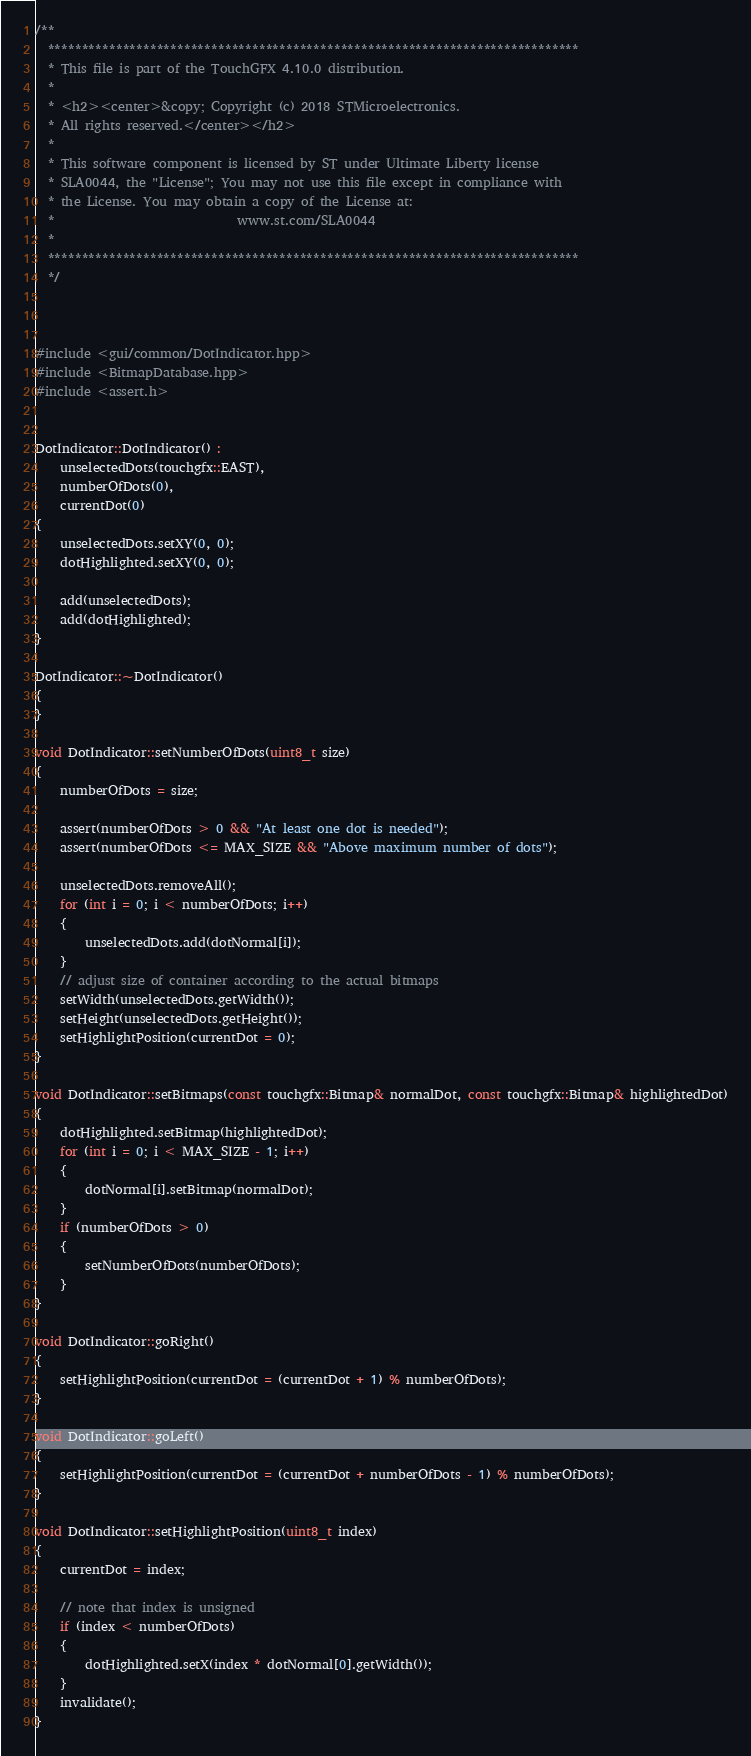Convert code to text. <code><loc_0><loc_0><loc_500><loc_500><_C++_>/**
  ******************************************************************************
  * This file is part of the TouchGFX 4.10.0 distribution.
  *
  * <h2><center>&copy; Copyright (c) 2018 STMicroelectronics.
  * All rights reserved.</center></h2>
  *
  * This software component is licensed by ST under Ultimate Liberty license
  * SLA0044, the "License"; You may not use this file except in compliance with
  * the License. You may obtain a copy of the License at:
  *                             www.st.com/SLA0044
  *
  ******************************************************************************
  */
  


#include <gui/common/DotIndicator.hpp>
#include <BitmapDatabase.hpp>
#include <assert.h>


DotIndicator::DotIndicator() :
    unselectedDots(touchgfx::EAST),
    numberOfDots(0),
    currentDot(0)
{
    unselectedDots.setXY(0, 0);
    dotHighlighted.setXY(0, 0);

    add(unselectedDots);
    add(dotHighlighted);
}

DotIndicator::~DotIndicator()
{
}

void DotIndicator::setNumberOfDots(uint8_t size)
{
    numberOfDots = size;

    assert(numberOfDots > 0 && "At least one dot is needed");
    assert(numberOfDots <= MAX_SIZE && "Above maximum number of dots");

    unselectedDots.removeAll();
    for (int i = 0; i < numberOfDots; i++)
    {
        unselectedDots.add(dotNormal[i]);
    }
    // adjust size of container according to the actual bitmaps
    setWidth(unselectedDots.getWidth());
    setHeight(unselectedDots.getHeight());
    setHighlightPosition(currentDot = 0);
}

void DotIndicator::setBitmaps(const touchgfx::Bitmap& normalDot, const touchgfx::Bitmap& highlightedDot)
{
    dotHighlighted.setBitmap(highlightedDot);
    for (int i = 0; i < MAX_SIZE - 1; i++)
    {
        dotNormal[i].setBitmap(normalDot);
    }
    if (numberOfDots > 0)
    {
        setNumberOfDots(numberOfDots);
    }
}

void DotIndicator::goRight()
{
    setHighlightPosition(currentDot = (currentDot + 1) % numberOfDots);
}

void DotIndicator::goLeft()
{
    setHighlightPosition(currentDot = (currentDot + numberOfDots - 1) % numberOfDots);
}

void DotIndicator::setHighlightPosition(uint8_t index)
{
    currentDot = index;

    // note that index is unsigned
    if (index < numberOfDots)
    {
        dotHighlighted.setX(index * dotNormal[0].getWidth());
    }
    invalidate();
}
</code> 